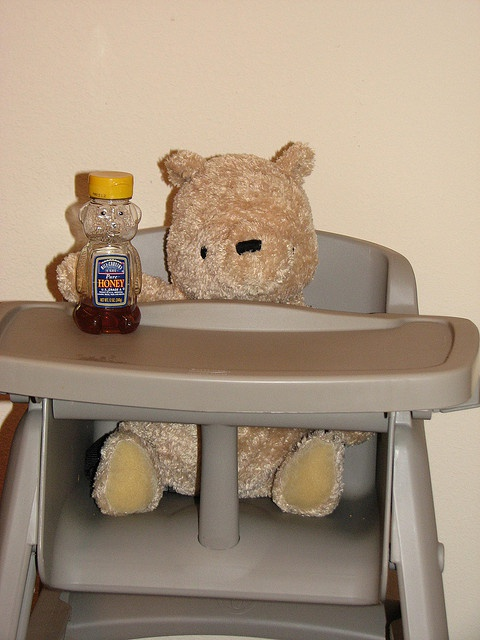Describe the objects in this image and their specific colors. I can see chair in tan, gray, and darkgray tones, teddy bear in tan and gray tones, and bottle in tan, black, gray, and maroon tones in this image. 